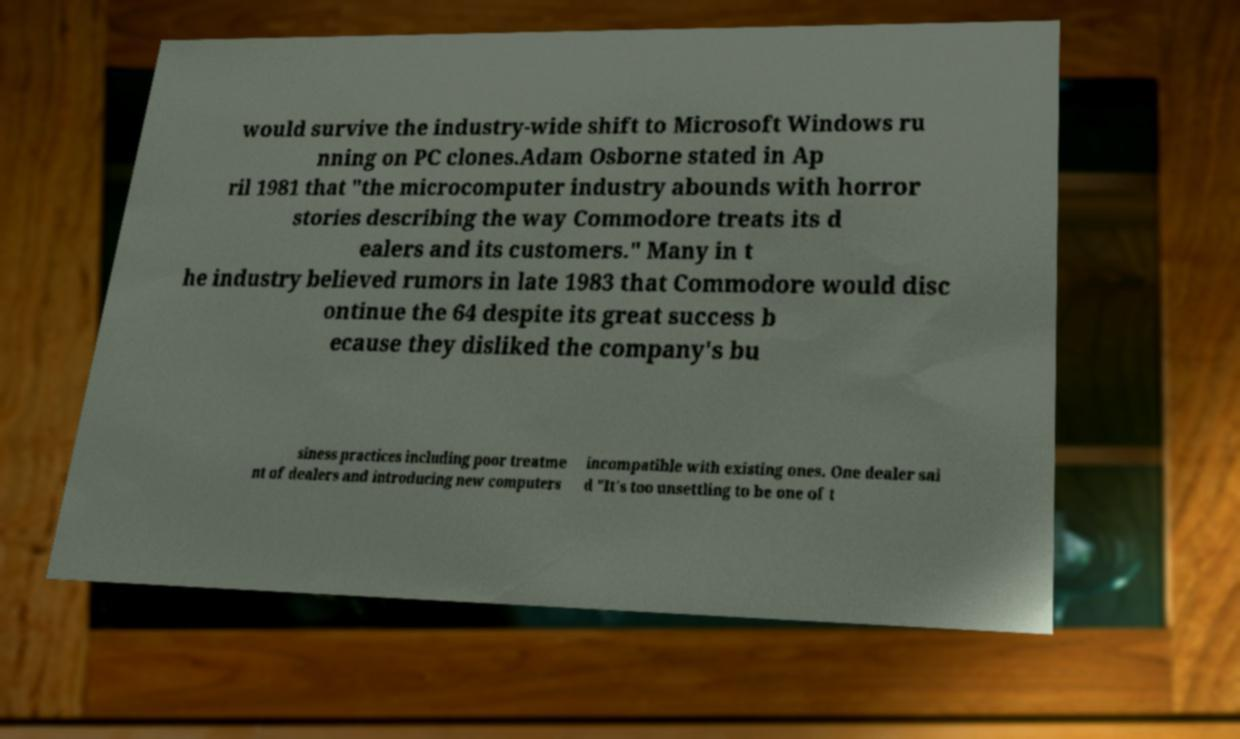Please identify and transcribe the text found in this image. would survive the industry-wide shift to Microsoft Windows ru nning on PC clones.Adam Osborne stated in Ap ril 1981 that "the microcomputer industry abounds with horror stories describing the way Commodore treats its d ealers and its customers." Many in t he industry believed rumors in late 1983 that Commodore would disc ontinue the 64 despite its great success b ecause they disliked the company's bu siness practices including poor treatme nt of dealers and introducing new computers incompatible with existing ones. One dealer sai d "It's too unsettling to be one of t 